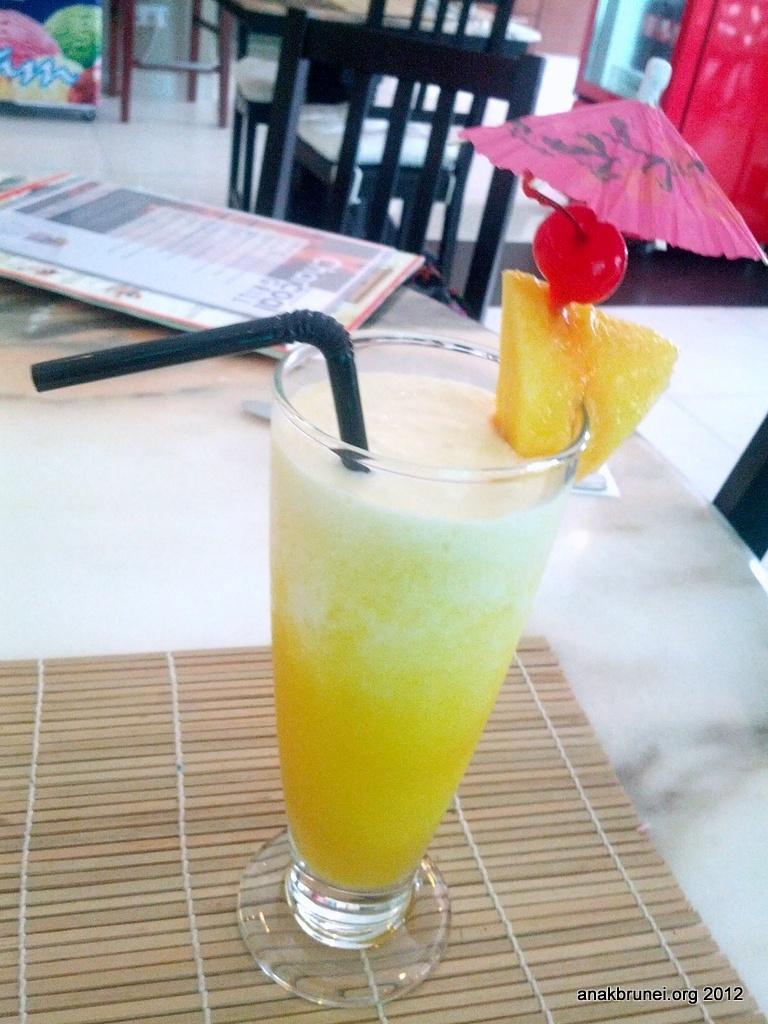Could you give a brief overview of what you see in this image? In this image we can see a drink which is in glass is of yellow color and there is a straw in it and there is menu card on table and in the background of the image there are some chairs and refrigerator. 